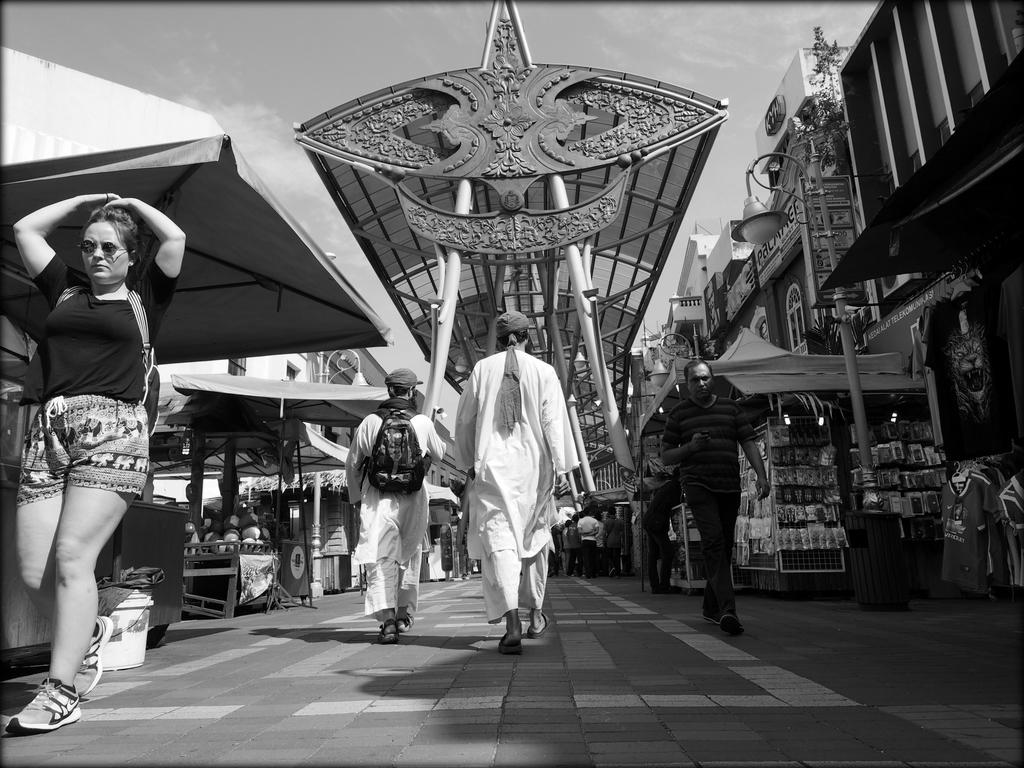Who or what can be seen in the image? There are persons in the image. What can be seen in the distance behind the persons? There are stalls and buildings visible in the background of the image. What is the condition of the sky in the image? The sky is visible at the top of the image. What type of roof is present in the image? There is a metal roof in the image. What type of drug can be seen in the image? There is no drug present in the image. What is the quiver used for in the image? There is no quiver present in the image. 